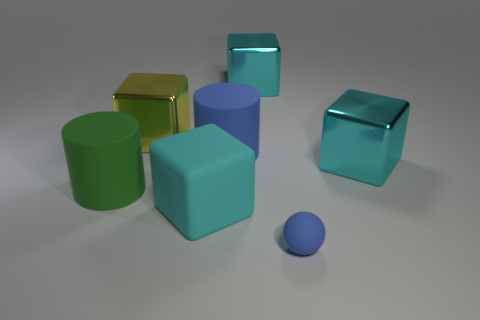Subtract all yellow balls. How many cyan cubes are left? 3 Subtract 1 cubes. How many cubes are left? 3 Add 3 big green rubber cylinders. How many objects exist? 10 Subtract all cubes. How many objects are left? 3 Subtract 0 red cylinders. How many objects are left? 7 Subtract all big rubber things. Subtract all green shiny objects. How many objects are left? 4 Add 2 large blue rubber cylinders. How many large blue rubber cylinders are left? 3 Add 3 balls. How many balls exist? 4 